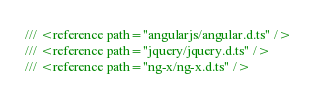<code> <loc_0><loc_0><loc_500><loc_500><_TypeScript_>/// <reference path="angularjs/angular.d.ts" />
/// <reference path="jquery/jquery.d.ts" />
/// <reference path="ng-x/ng-x.d.ts" />
</code> 